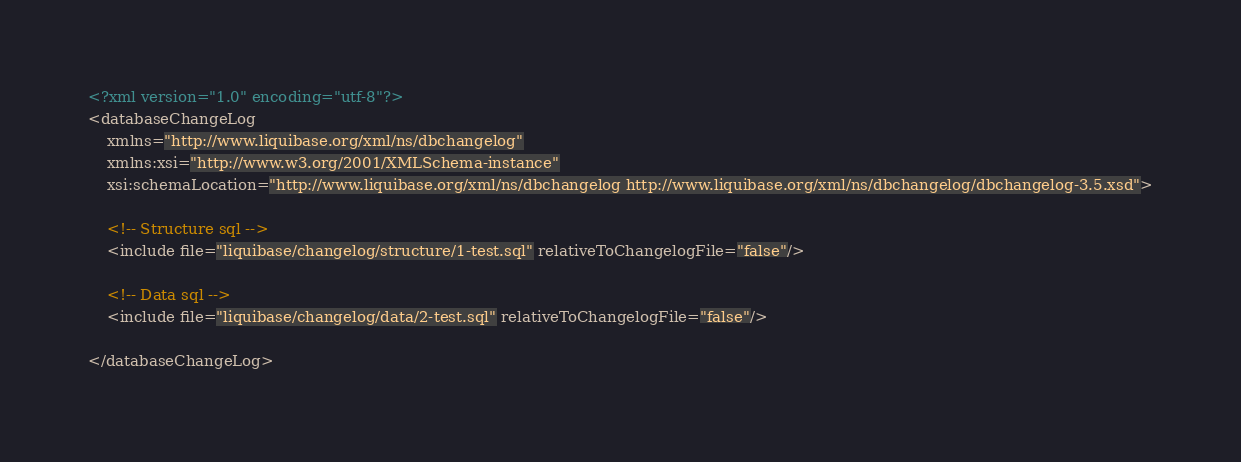<code> <loc_0><loc_0><loc_500><loc_500><_XML_><?xml version="1.0" encoding="utf-8"?>
<databaseChangeLog
    xmlns="http://www.liquibase.org/xml/ns/dbchangelog"
    xmlns:xsi="http://www.w3.org/2001/XMLSchema-instance"
    xsi:schemaLocation="http://www.liquibase.org/xml/ns/dbchangelog http://www.liquibase.org/xml/ns/dbchangelog/dbchangelog-3.5.xsd">

    <!-- Structure sql -->
    <include file="liquibase/changelog/structure/1-test.sql" relativeToChangelogFile="false"/>

    <!-- Data sql -->
    <include file="liquibase/changelog/data/2-test.sql" relativeToChangelogFile="false"/>

</databaseChangeLog>
</code> 